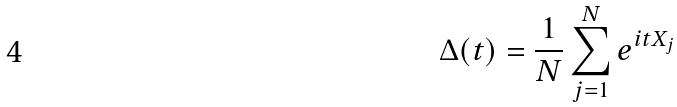Convert formula to latex. <formula><loc_0><loc_0><loc_500><loc_500>\Delta ( t ) = \frac { 1 } { N } \sum _ { j = 1 } ^ { N } e ^ { i t X _ { j } }</formula> 